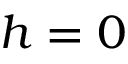<formula> <loc_0><loc_0><loc_500><loc_500>h = 0</formula> 